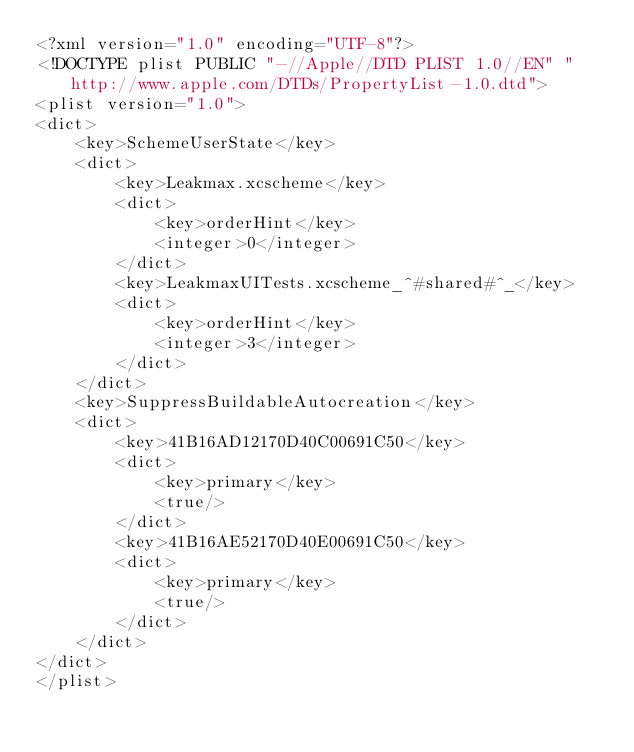Convert code to text. <code><loc_0><loc_0><loc_500><loc_500><_XML_><?xml version="1.0" encoding="UTF-8"?>
<!DOCTYPE plist PUBLIC "-//Apple//DTD PLIST 1.0//EN" "http://www.apple.com/DTDs/PropertyList-1.0.dtd">
<plist version="1.0">
<dict>
	<key>SchemeUserState</key>
	<dict>
		<key>Leakmax.xcscheme</key>
		<dict>
			<key>orderHint</key>
			<integer>0</integer>
		</dict>
		<key>LeakmaxUITests.xcscheme_^#shared#^_</key>
		<dict>
			<key>orderHint</key>
			<integer>3</integer>
		</dict>
	</dict>
	<key>SuppressBuildableAutocreation</key>
	<dict>
		<key>41B16AD12170D40C00691C50</key>
		<dict>
			<key>primary</key>
			<true/>
		</dict>
		<key>41B16AE52170D40E00691C50</key>
		<dict>
			<key>primary</key>
			<true/>
		</dict>
	</dict>
</dict>
</plist>
</code> 